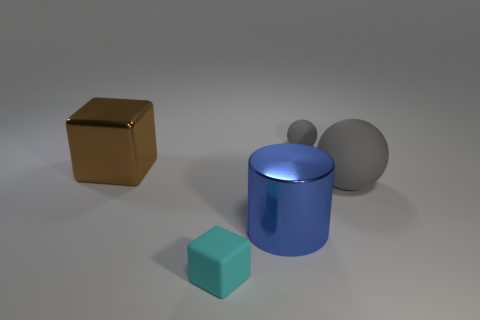Add 3 gray objects. How many objects exist? 8 Subtract all cylinders. How many objects are left? 4 Subtract all big blue cylinders. Subtract all brown metal things. How many objects are left? 3 Add 1 balls. How many balls are left? 3 Add 1 small rubber blocks. How many small rubber blocks exist? 2 Subtract 1 gray spheres. How many objects are left? 4 Subtract all yellow cubes. Subtract all gray cylinders. How many cubes are left? 2 